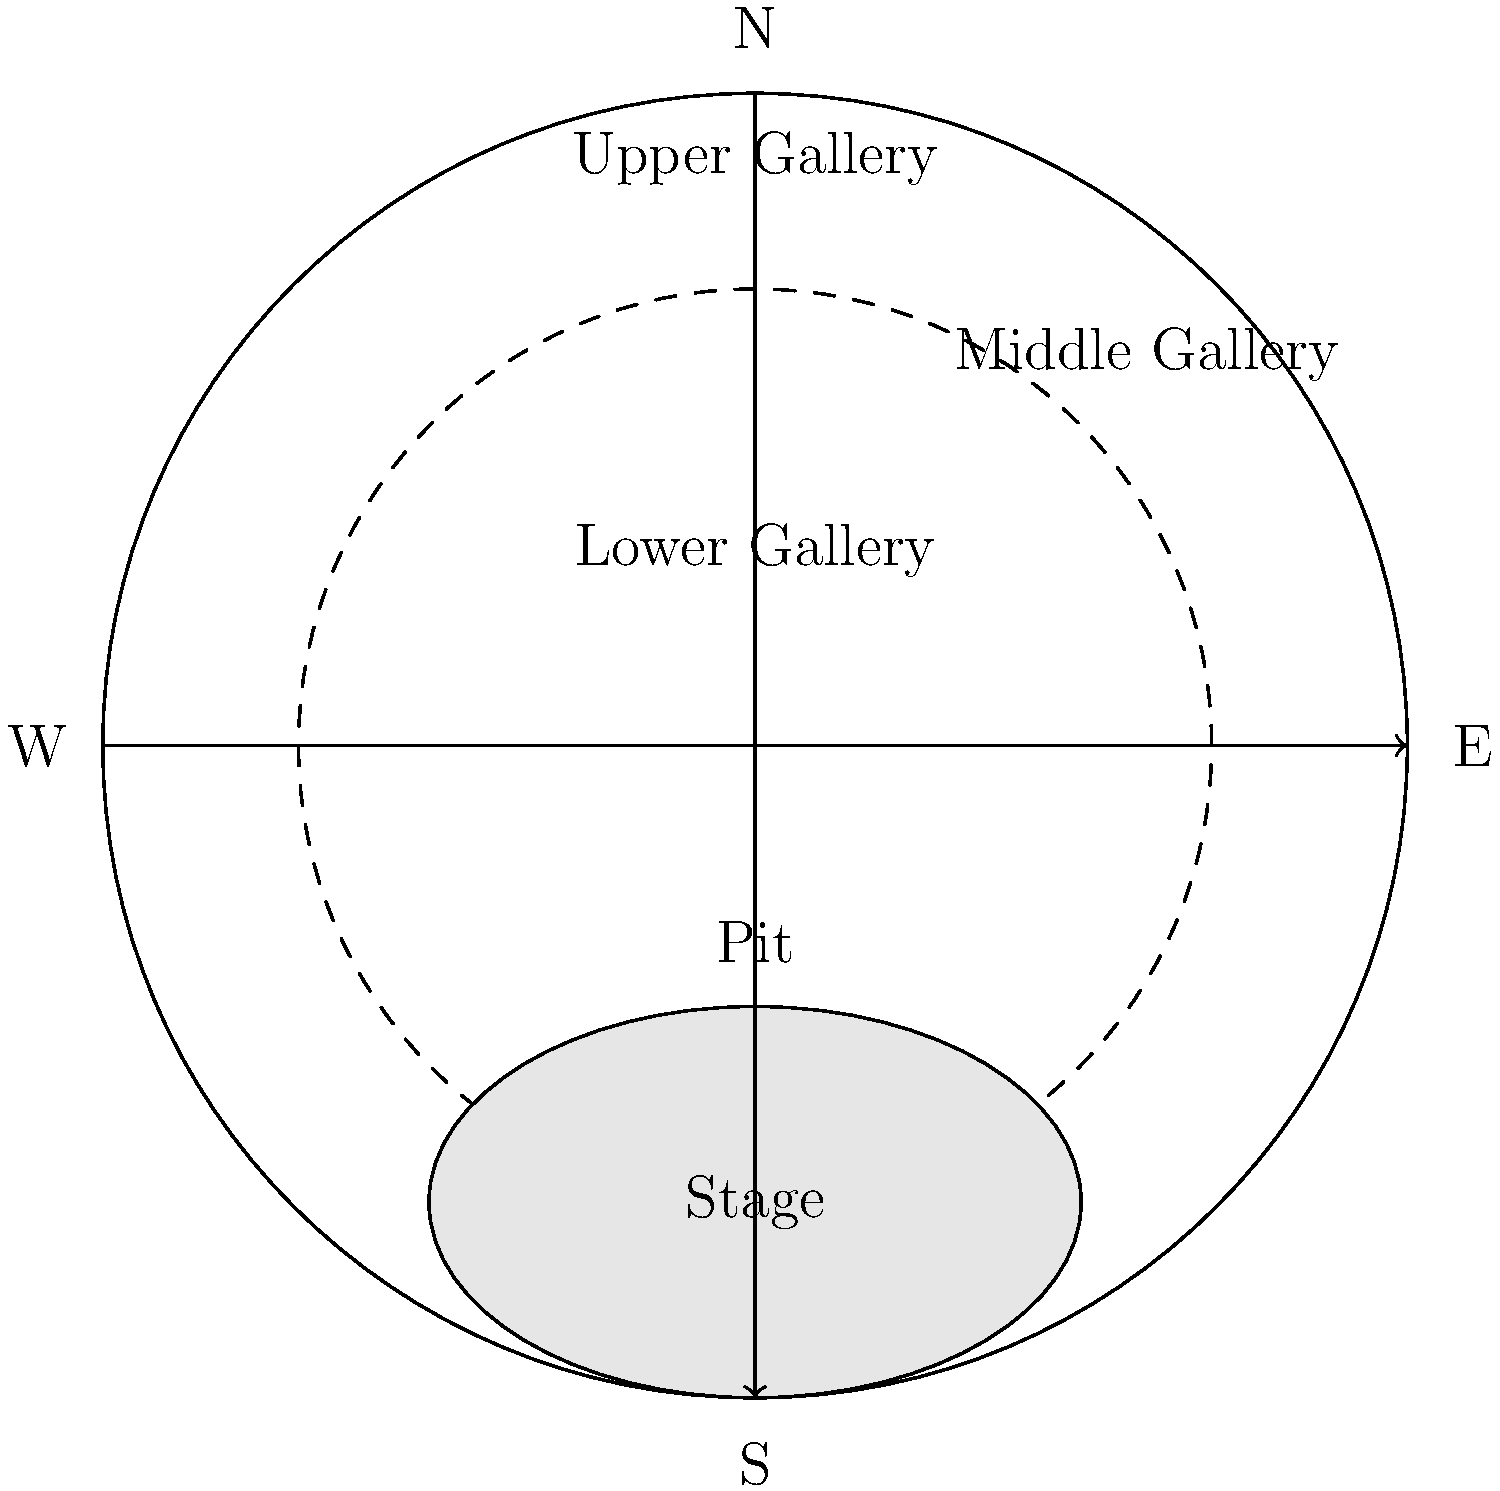In the diagram of the Globe Theatre, which section is located directly above the stage and would have been the most expensive seating area? To answer this question, let's analyze the layout of the Globe Theatre as shown in the diagram:

1. The stage is clearly labeled at the bottom of the circular structure.
2. Above the stage, we can see three levels of seating areas arranged in a semi-circular fashion.
3. These levels are labeled, from bottom to top, as:
   - Lower Gallery
   - Middle Gallery
   - Upper Gallery
4. In Shakespearean times, the most expensive seats were typically those closest to the stage and with the best view.
5. Of the three gallery levels, the Lower Gallery is the closest to the stage.
6. The Lower Gallery is directly above the stage area.
7. Being the closest to the action and providing the best view, the Lower Gallery would have been the most expensive seating area.

Therefore, the section located directly above the stage and likely the most expensive seating area is the Lower Gallery.
Answer: Lower Gallery 